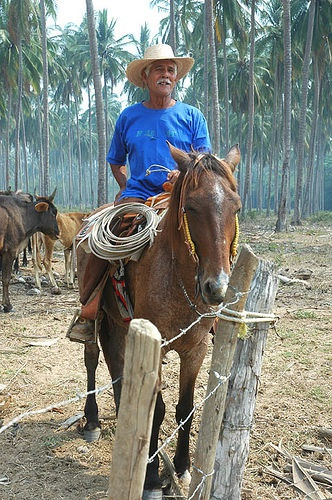Describe the objects in this image and their specific colors. I can see horse in teal, black, maroon, and gray tones, people in teal, blue, and gray tones, cow in teal, gray, and black tones, and cow in teal, tan, darkgray, and gray tones in this image. 